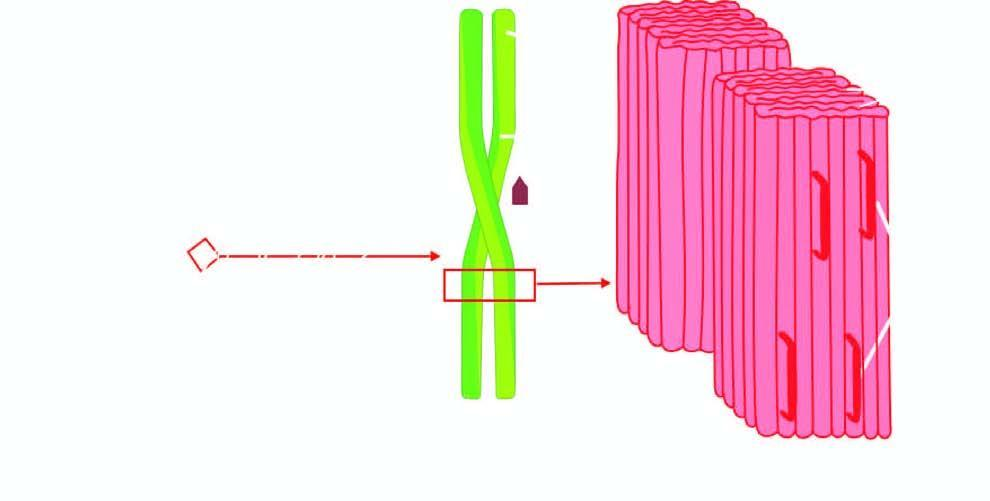what is further composed of two pleated sheets in the form of twin filaments separated by a clear space?
Answer the question using a single word or phrase. Each fibril 